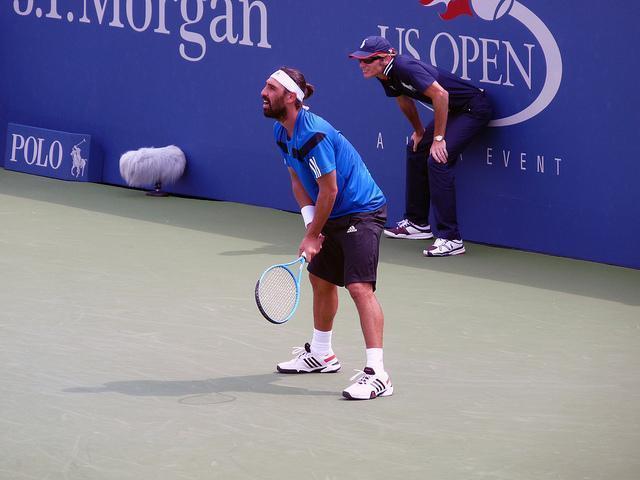What do the sunglasses worn here serve as?
Choose the right answer from the provided options to respond to the question.
Options: Trauma protection, nothing, glare protection, fashion only. Glare protection. 